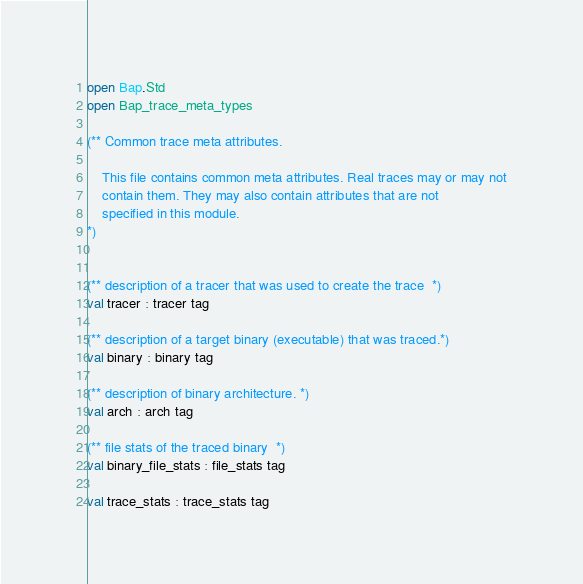<code> <loc_0><loc_0><loc_500><loc_500><_OCaml_>open Bap.Std
open Bap_trace_meta_types

(** Common trace meta attributes.

    This file contains common meta attributes. Real traces may or may not
    contain them. They may also contain attributes that are not
    specified in this module.
*)


(** description of a tracer that was used to create the trace  *)
val tracer : tracer tag

(** description of a target binary (executable) that was traced.*)
val binary : binary tag

(** description of binary architecture. *)
val arch : arch tag

(** file stats of the traced binary  *)
val binary_file_stats : file_stats tag

val trace_stats : trace_stats tag
</code> 